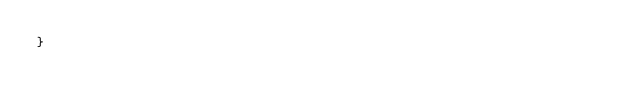Convert code to text. <code><loc_0><loc_0><loc_500><loc_500><_TypeScript_>}
</code> 